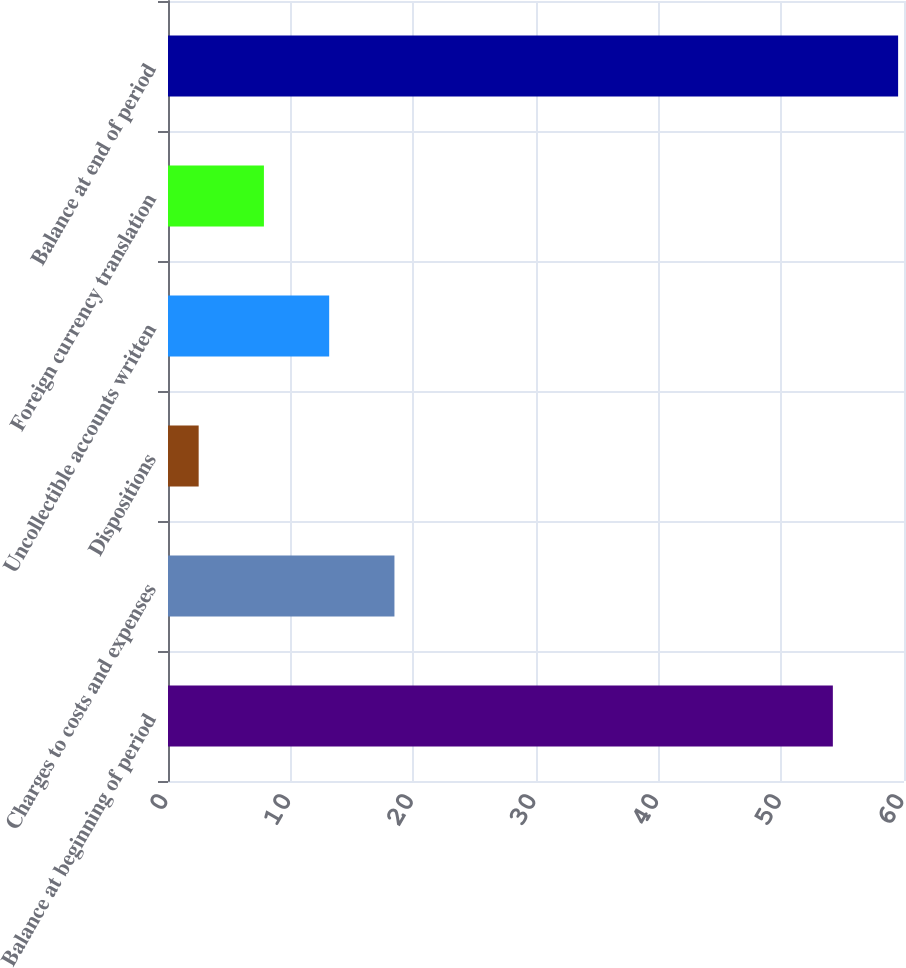Convert chart. <chart><loc_0><loc_0><loc_500><loc_500><bar_chart><fcel>Balance at beginning of period<fcel>Charges to costs and expenses<fcel>Dispositions<fcel>Uncollectible accounts written<fcel>Foreign currency translation<fcel>Balance at end of period<nl><fcel>54.2<fcel>18.46<fcel>2.5<fcel>13.14<fcel>7.82<fcel>59.52<nl></chart> 